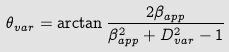<formula> <loc_0><loc_0><loc_500><loc_500>\theta _ { v a r } = \arctan \frac { 2 \beta _ { a p p } } { \beta _ { a p p } ^ { 2 } + D _ { v a r } ^ { 2 } - 1 }</formula> 